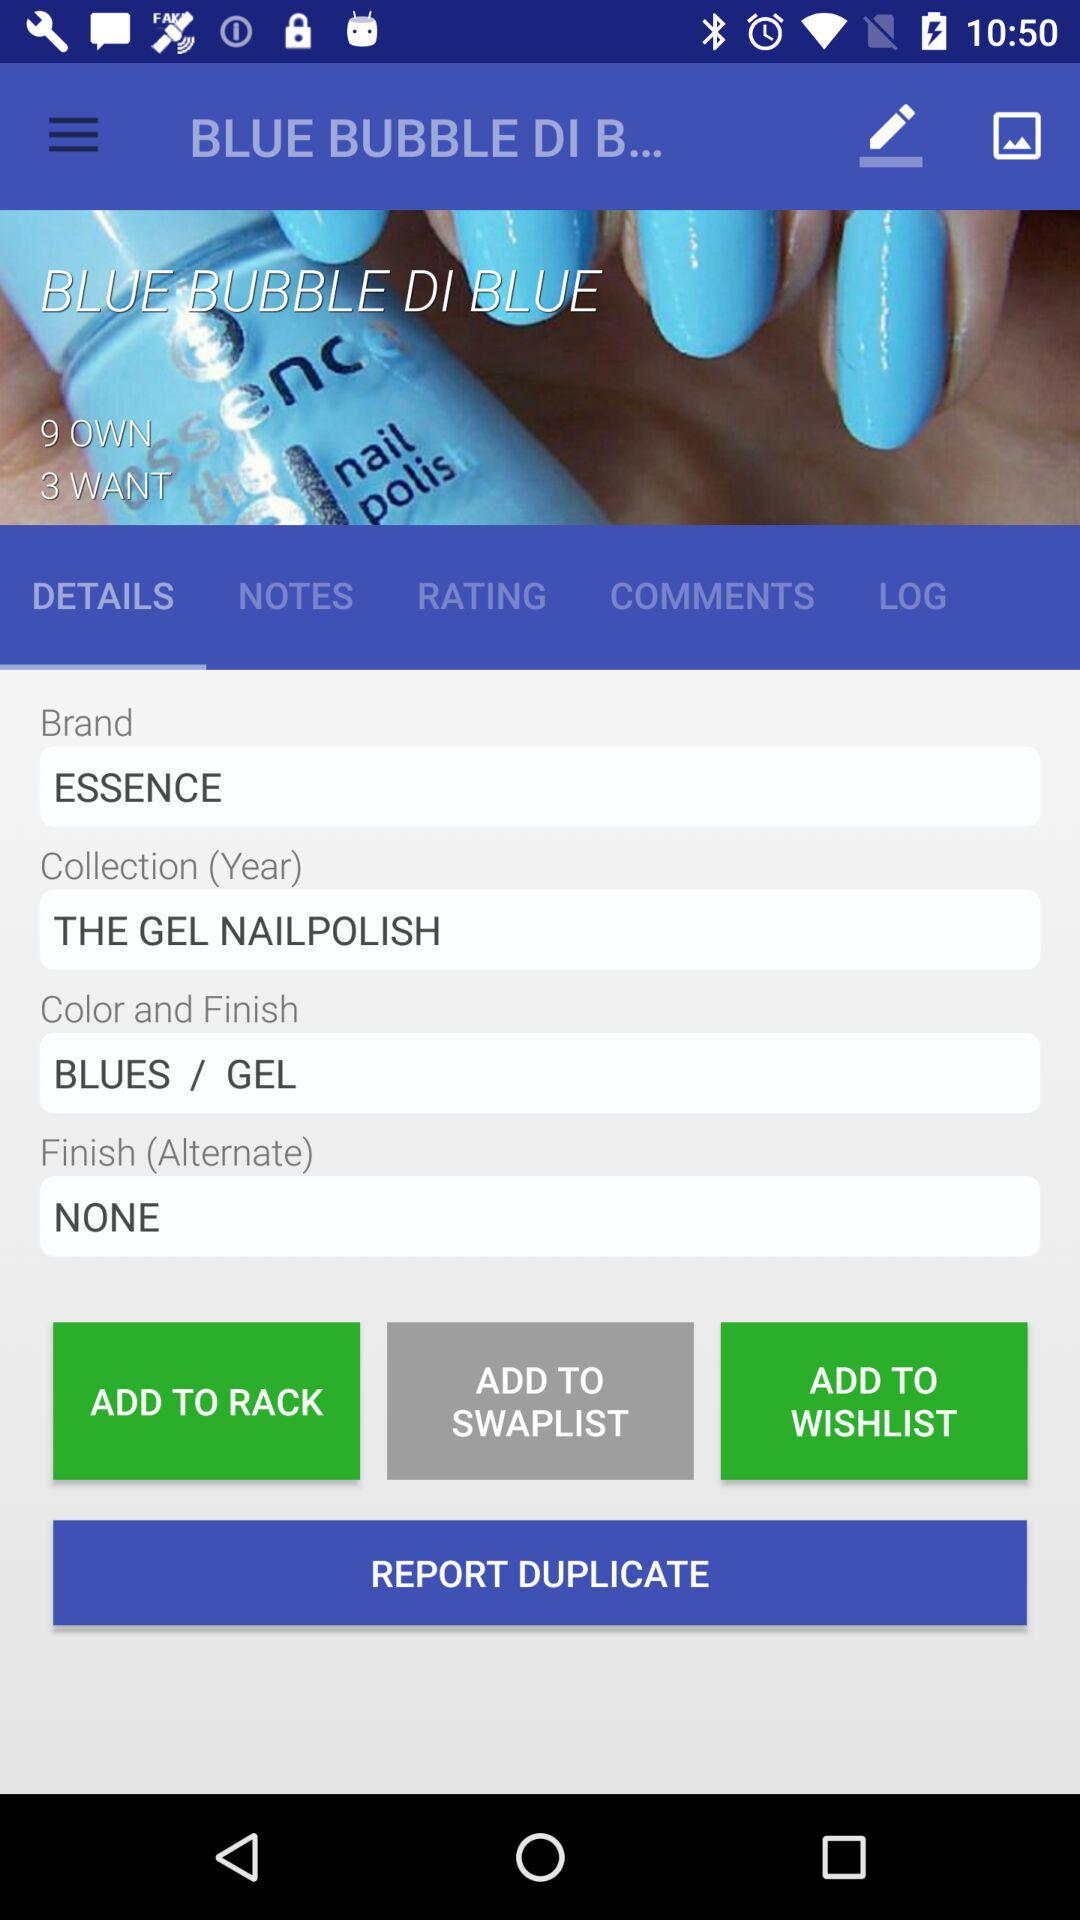What is the number of items owned? The number of items is 9. 